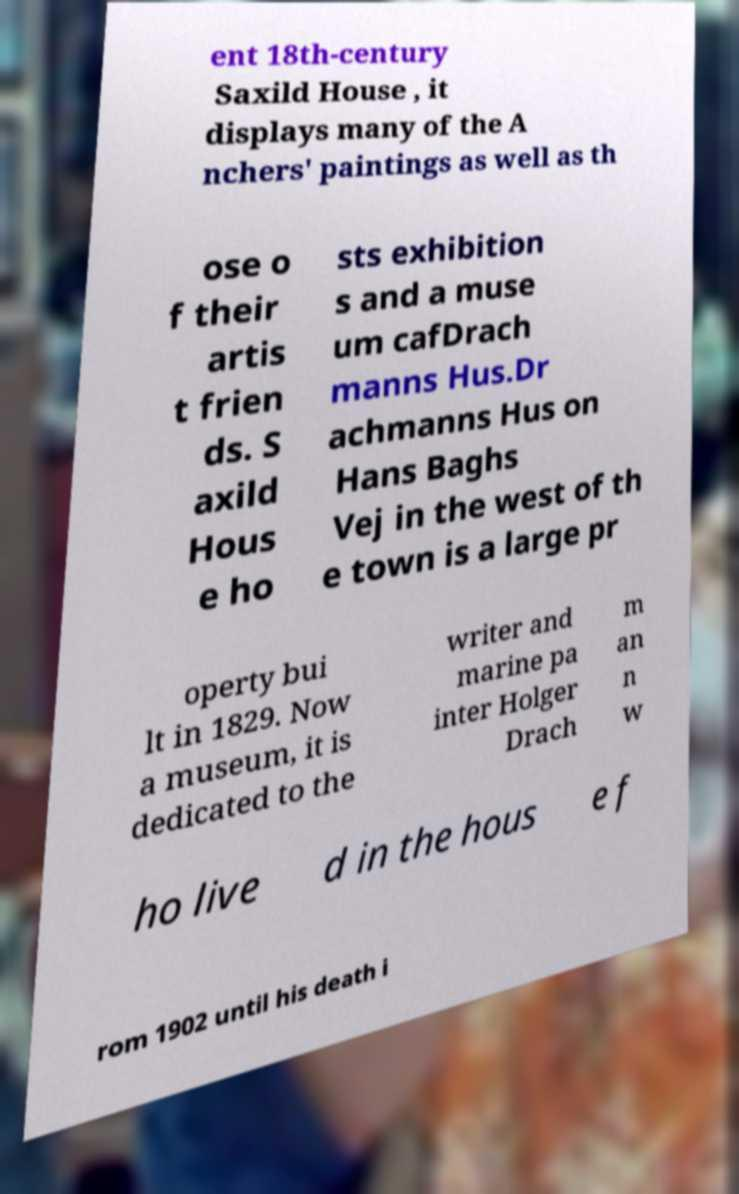Please read and relay the text visible in this image. What does it say? ent 18th-century Saxild House , it displays many of the A nchers' paintings as well as th ose o f their artis t frien ds. S axild Hous e ho sts exhibition s and a muse um cafDrach manns Hus.Dr achmanns Hus on Hans Baghs Vej in the west of th e town is a large pr operty bui lt in 1829. Now a museum, it is dedicated to the writer and marine pa inter Holger Drach m an n w ho live d in the hous e f rom 1902 until his death i 